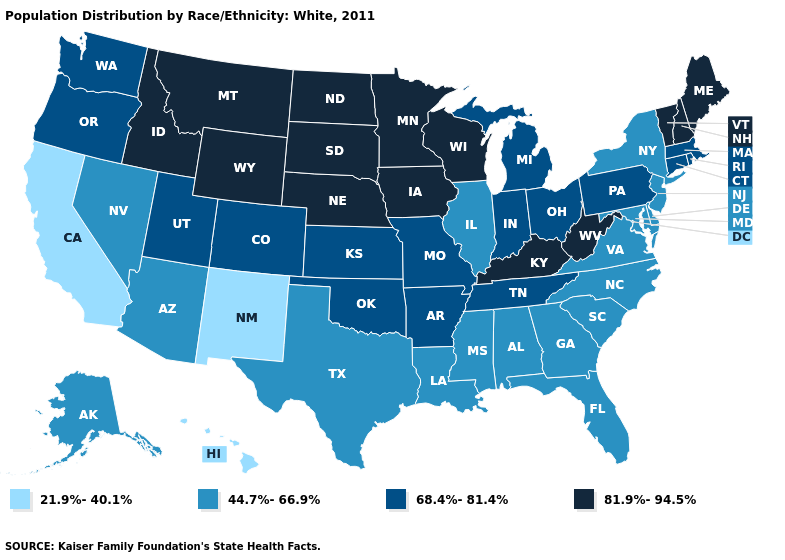What is the value of West Virginia?
Short answer required. 81.9%-94.5%. Does Georgia have the same value as Tennessee?
Short answer required. No. Name the states that have a value in the range 44.7%-66.9%?
Give a very brief answer. Alabama, Alaska, Arizona, Delaware, Florida, Georgia, Illinois, Louisiana, Maryland, Mississippi, Nevada, New Jersey, New York, North Carolina, South Carolina, Texas, Virginia. What is the value of New Mexico?
Short answer required. 21.9%-40.1%. Which states have the highest value in the USA?
Give a very brief answer. Idaho, Iowa, Kentucky, Maine, Minnesota, Montana, Nebraska, New Hampshire, North Dakota, South Dakota, Vermont, West Virginia, Wisconsin, Wyoming. Name the states that have a value in the range 81.9%-94.5%?
Answer briefly. Idaho, Iowa, Kentucky, Maine, Minnesota, Montana, Nebraska, New Hampshire, North Dakota, South Dakota, Vermont, West Virginia, Wisconsin, Wyoming. Which states hav the highest value in the South?
Keep it brief. Kentucky, West Virginia. What is the lowest value in the USA?
Keep it brief. 21.9%-40.1%. What is the value of Delaware?
Give a very brief answer. 44.7%-66.9%. Name the states that have a value in the range 81.9%-94.5%?
Be succinct. Idaho, Iowa, Kentucky, Maine, Minnesota, Montana, Nebraska, New Hampshire, North Dakota, South Dakota, Vermont, West Virginia, Wisconsin, Wyoming. Does the first symbol in the legend represent the smallest category?
Give a very brief answer. Yes. Name the states that have a value in the range 81.9%-94.5%?
Write a very short answer. Idaho, Iowa, Kentucky, Maine, Minnesota, Montana, Nebraska, New Hampshire, North Dakota, South Dakota, Vermont, West Virginia, Wisconsin, Wyoming. Does Alabama have a higher value than Arkansas?
Quick response, please. No. Name the states that have a value in the range 68.4%-81.4%?
Write a very short answer. Arkansas, Colorado, Connecticut, Indiana, Kansas, Massachusetts, Michigan, Missouri, Ohio, Oklahoma, Oregon, Pennsylvania, Rhode Island, Tennessee, Utah, Washington. Does Montana have the highest value in the USA?
Quick response, please. Yes. 